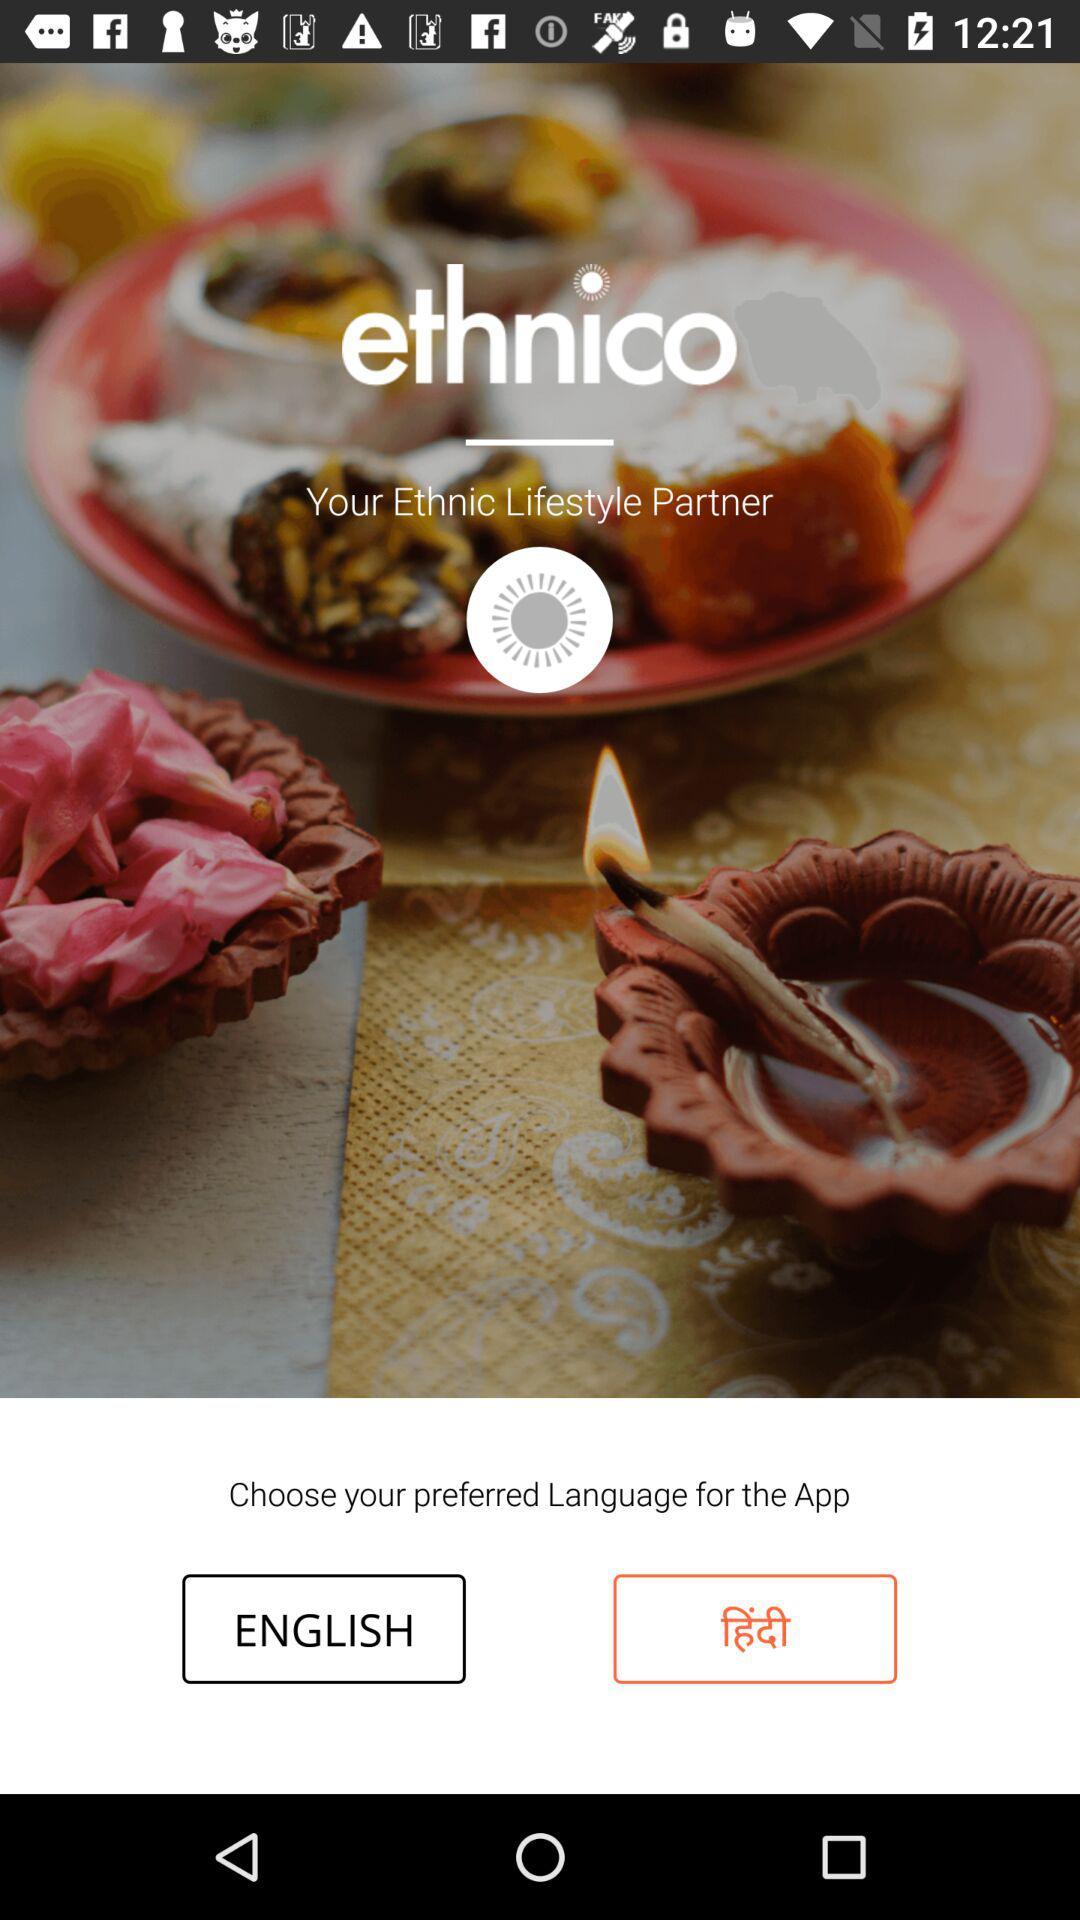What is the name of the application? The name of the application is "ethnico". 